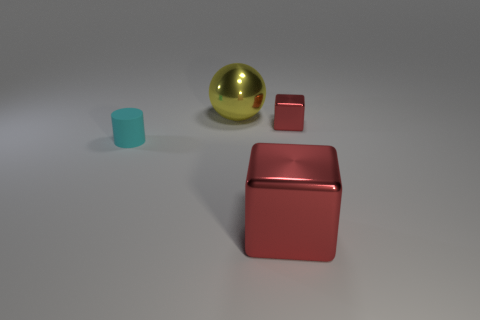There is another shiny object that is the same color as the small metallic thing; what size is it?
Your answer should be very brief. Large. There is a big shiny object that is in front of the small metallic block to the right of the big yellow sphere; what is its color?
Make the answer very short. Red. Does the tiny red block have the same material as the red block that is in front of the cyan matte cylinder?
Provide a short and direct response. Yes. What is the large thing right of the big sphere made of?
Your answer should be very brief. Metal. Is the number of cyan rubber things left of the large metal cube the same as the number of small green matte objects?
Provide a succinct answer. No. Is there anything else that is the same size as the yellow sphere?
Make the answer very short. Yes. There is a red block that is on the right side of the large object that is to the right of the yellow shiny object; what is its material?
Your response must be concise. Metal. There is a thing that is in front of the small red cube and right of the cyan rubber thing; what is its shape?
Provide a succinct answer. Cube. There is another thing that is the same shape as the large red thing; what is its size?
Give a very brief answer. Small. Are there fewer large red metallic things that are on the left side of the large yellow metal object than tiny cubes?
Your response must be concise. Yes. 